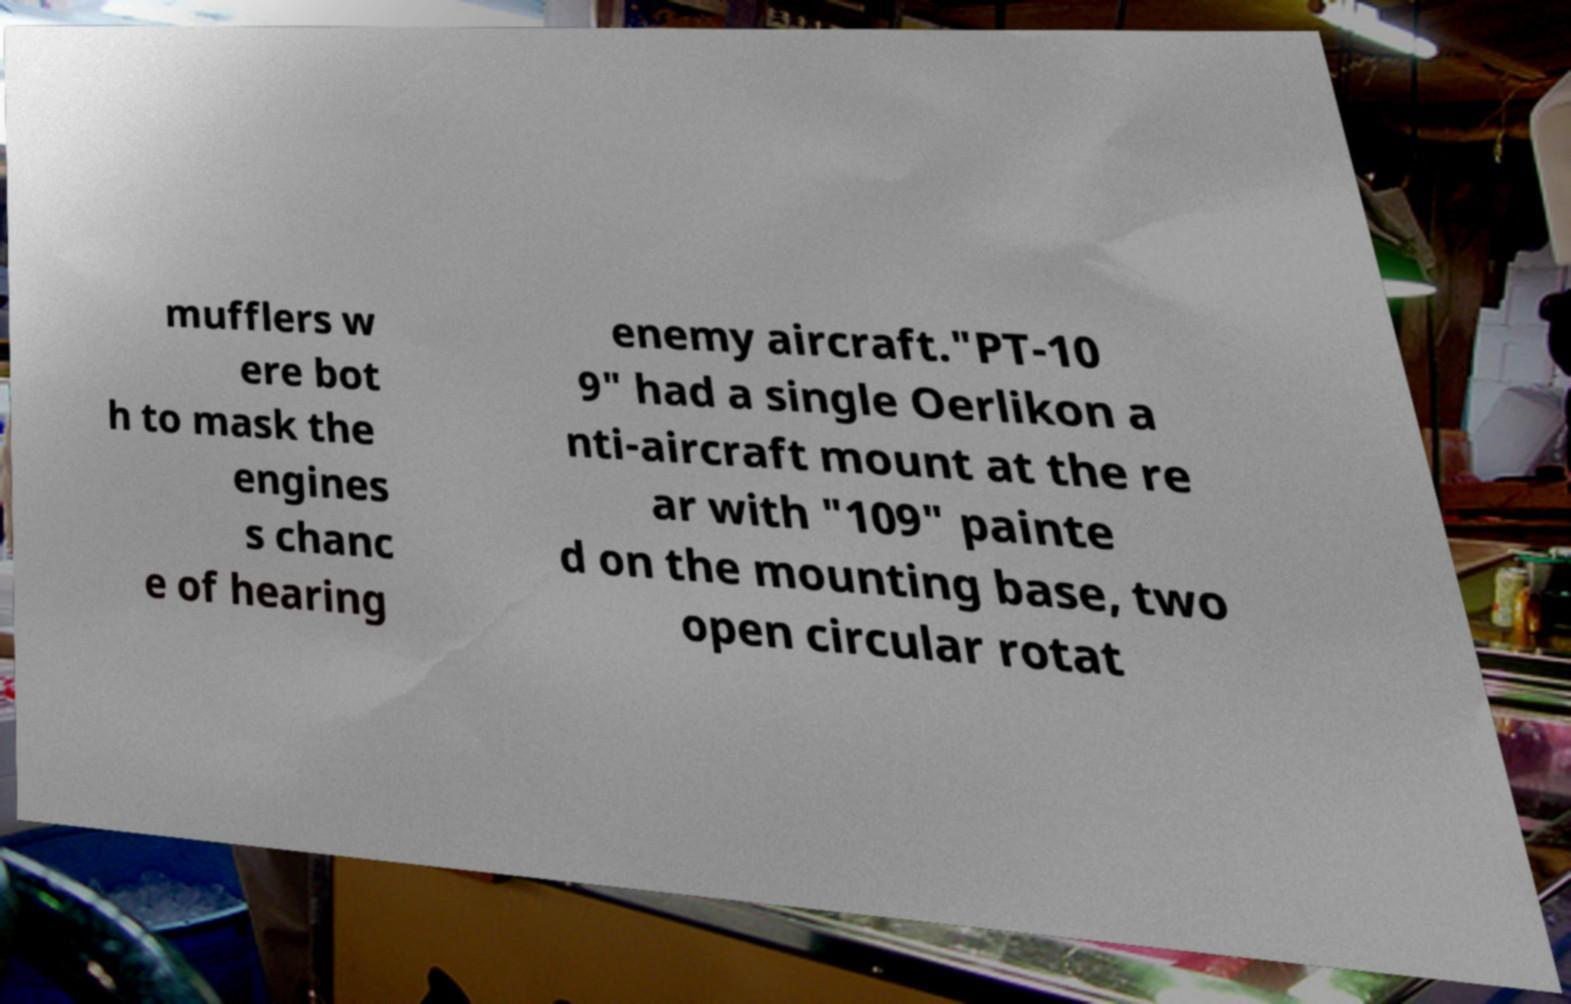Could you extract and type out the text from this image? mufflers w ere bot h to mask the engines s chanc e of hearing enemy aircraft."PT-10 9" had a single Oerlikon a nti-aircraft mount at the re ar with "109" painte d on the mounting base, two open circular rotat 